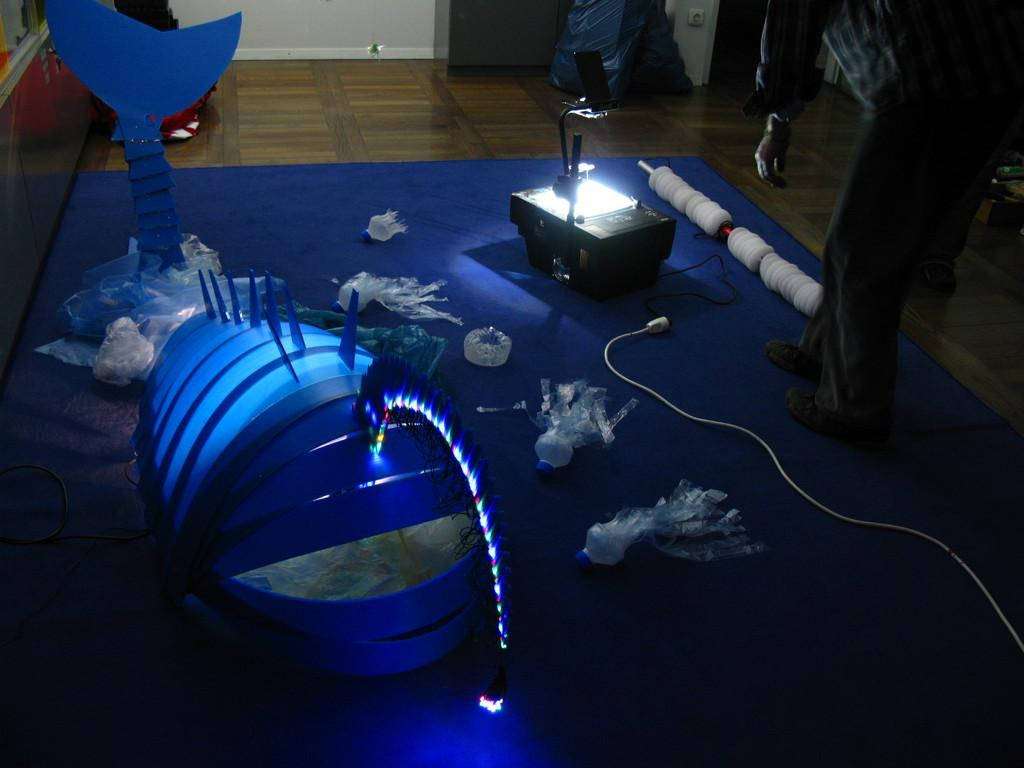What can be seen in the image that resembles a plaything? There is a toy in the image. What source of illumination is present in the image? There is a light in the image. What connects the light to a power source? There is a cable in the image. What surface do the other objects in the image rest on? There are other objects on a mat in the image. What can be seen on the right side of the image that indicates the presence of people? There are legs of two persons standing on the floor on the right side of the image. Is the grape being used as a toy in the image? There is no grape present in the image. How does the visitor interact with the objects on the mat in the image? There is no visitor present in the image. 